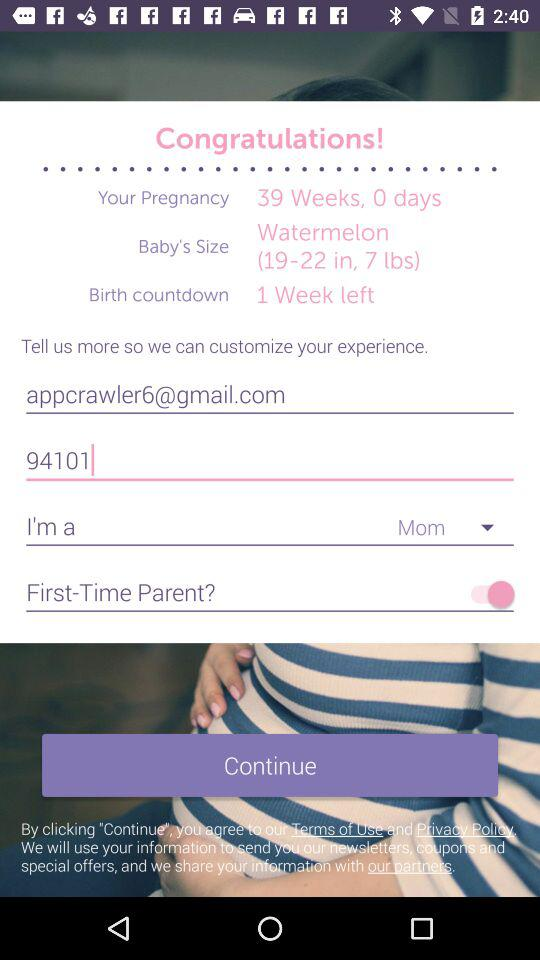What is the status of "First-Time Parent?"? The status is "on". 